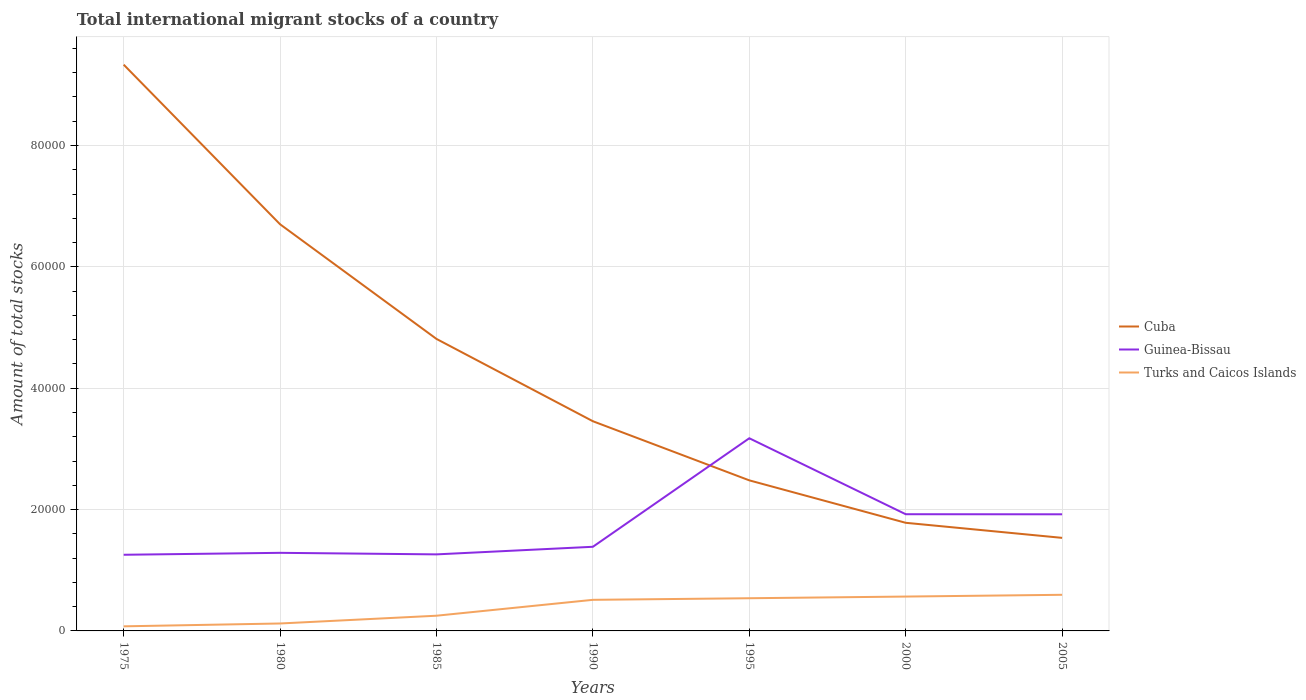How many different coloured lines are there?
Your answer should be very brief. 3. Across all years, what is the maximum amount of total stocks in in Cuba?
Your response must be concise. 1.53e+04. In which year was the amount of total stocks in in Guinea-Bissau maximum?
Offer a terse response. 1975. What is the total amount of total stocks in in Guinea-Bissau in the graph?
Your answer should be very brief. -318. What is the difference between the highest and the second highest amount of total stocks in in Turks and Caicos Islands?
Ensure brevity in your answer.  5196. What is the difference between the highest and the lowest amount of total stocks in in Cuba?
Give a very brief answer. 3. How many lines are there?
Provide a succinct answer. 3. Are the values on the major ticks of Y-axis written in scientific E-notation?
Offer a terse response. No. Does the graph contain grids?
Ensure brevity in your answer.  Yes. How many legend labels are there?
Provide a succinct answer. 3. How are the legend labels stacked?
Offer a terse response. Vertical. What is the title of the graph?
Give a very brief answer. Total international migrant stocks of a country. What is the label or title of the X-axis?
Ensure brevity in your answer.  Years. What is the label or title of the Y-axis?
Give a very brief answer. Amount of total stocks. What is the Amount of total stocks of Cuba in 1975?
Make the answer very short. 9.33e+04. What is the Amount of total stocks of Guinea-Bissau in 1975?
Provide a short and direct response. 1.26e+04. What is the Amount of total stocks in Turks and Caicos Islands in 1975?
Provide a succinct answer. 756. What is the Amount of total stocks of Cuba in 1980?
Offer a very short reply. 6.70e+04. What is the Amount of total stocks in Guinea-Bissau in 1980?
Keep it short and to the point. 1.29e+04. What is the Amount of total stocks of Turks and Caicos Islands in 1980?
Ensure brevity in your answer.  1225. What is the Amount of total stocks in Cuba in 1985?
Make the answer very short. 4.81e+04. What is the Amount of total stocks of Guinea-Bissau in 1985?
Your answer should be very brief. 1.26e+04. What is the Amount of total stocks in Turks and Caicos Islands in 1985?
Your answer should be compact. 2506. What is the Amount of total stocks of Cuba in 1990?
Your answer should be compact. 3.46e+04. What is the Amount of total stocks in Guinea-Bissau in 1990?
Make the answer very short. 1.39e+04. What is the Amount of total stocks of Turks and Caicos Islands in 1990?
Keep it short and to the point. 5124. What is the Amount of total stocks of Cuba in 1995?
Provide a succinct answer. 2.48e+04. What is the Amount of total stocks in Guinea-Bissau in 1995?
Your answer should be compact. 3.17e+04. What is the Amount of total stocks of Turks and Caicos Islands in 1995?
Your answer should be compact. 5386. What is the Amount of total stocks of Cuba in 2000?
Your response must be concise. 1.78e+04. What is the Amount of total stocks of Guinea-Bissau in 2000?
Offer a terse response. 1.92e+04. What is the Amount of total stocks of Turks and Caicos Islands in 2000?
Provide a succinct answer. 5662. What is the Amount of total stocks in Cuba in 2005?
Your response must be concise. 1.53e+04. What is the Amount of total stocks of Guinea-Bissau in 2005?
Your response must be concise. 1.92e+04. What is the Amount of total stocks in Turks and Caicos Islands in 2005?
Give a very brief answer. 5952. Across all years, what is the maximum Amount of total stocks of Cuba?
Give a very brief answer. 9.33e+04. Across all years, what is the maximum Amount of total stocks in Guinea-Bissau?
Provide a succinct answer. 3.17e+04. Across all years, what is the maximum Amount of total stocks in Turks and Caicos Islands?
Give a very brief answer. 5952. Across all years, what is the minimum Amount of total stocks in Cuba?
Give a very brief answer. 1.53e+04. Across all years, what is the minimum Amount of total stocks in Guinea-Bissau?
Provide a succinct answer. 1.26e+04. Across all years, what is the minimum Amount of total stocks of Turks and Caicos Islands?
Offer a terse response. 756. What is the total Amount of total stocks in Cuba in the graph?
Provide a succinct answer. 3.01e+05. What is the total Amount of total stocks in Guinea-Bissau in the graph?
Provide a succinct answer. 1.22e+05. What is the total Amount of total stocks of Turks and Caicos Islands in the graph?
Give a very brief answer. 2.66e+04. What is the difference between the Amount of total stocks of Cuba in 1975 and that in 1980?
Your answer should be compact. 2.63e+04. What is the difference between the Amount of total stocks of Guinea-Bissau in 1975 and that in 1980?
Give a very brief answer. -318. What is the difference between the Amount of total stocks in Turks and Caicos Islands in 1975 and that in 1980?
Your response must be concise. -469. What is the difference between the Amount of total stocks in Cuba in 1975 and that in 1985?
Offer a very short reply. 4.52e+04. What is the difference between the Amount of total stocks in Guinea-Bissau in 1975 and that in 1985?
Provide a succinct answer. -63. What is the difference between the Amount of total stocks of Turks and Caicos Islands in 1975 and that in 1985?
Offer a very short reply. -1750. What is the difference between the Amount of total stocks of Cuba in 1975 and that in 1990?
Keep it short and to the point. 5.88e+04. What is the difference between the Amount of total stocks of Guinea-Bissau in 1975 and that in 1990?
Offer a very short reply. -1315. What is the difference between the Amount of total stocks of Turks and Caicos Islands in 1975 and that in 1990?
Provide a succinct answer. -4368. What is the difference between the Amount of total stocks of Cuba in 1975 and that in 1995?
Keep it short and to the point. 6.85e+04. What is the difference between the Amount of total stocks in Guinea-Bissau in 1975 and that in 1995?
Ensure brevity in your answer.  -1.92e+04. What is the difference between the Amount of total stocks of Turks and Caicos Islands in 1975 and that in 1995?
Provide a succinct answer. -4630. What is the difference between the Amount of total stocks in Cuba in 1975 and that in 2000?
Keep it short and to the point. 7.55e+04. What is the difference between the Amount of total stocks of Guinea-Bissau in 1975 and that in 2000?
Your answer should be compact. -6682. What is the difference between the Amount of total stocks in Turks and Caicos Islands in 1975 and that in 2000?
Provide a succinct answer. -4906. What is the difference between the Amount of total stocks of Cuba in 1975 and that in 2005?
Ensure brevity in your answer.  7.80e+04. What is the difference between the Amount of total stocks in Guinea-Bissau in 1975 and that in 2005?
Offer a very short reply. -6668. What is the difference between the Amount of total stocks of Turks and Caicos Islands in 1975 and that in 2005?
Keep it short and to the point. -5196. What is the difference between the Amount of total stocks of Cuba in 1980 and that in 1985?
Provide a short and direct response. 1.89e+04. What is the difference between the Amount of total stocks in Guinea-Bissau in 1980 and that in 1985?
Offer a very short reply. 255. What is the difference between the Amount of total stocks of Turks and Caicos Islands in 1980 and that in 1985?
Your answer should be very brief. -1281. What is the difference between the Amount of total stocks in Cuba in 1980 and that in 1990?
Your response must be concise. 3.25e+04. What is the difference between the Amount of total stocks in Guinea-Bissau in 1980 and that in 1990?
Provide a succinct answer. -997. What is the difference between the Amount of total stocks of Turks and Caicos Islands in 1980 and that in 1990?
Make the answer very short. -3899. What is the difference between the Amount of total stocks in Cuba in 1980 and that in 1995?
Provide a succinct answer. 4.22e+04. What is the difference between the Amount of total stocks of Guinea-Bissau in 1980 and that in 1995?
Offer a very short reply. -1.89e+04. What is the difference between the Amount of total stocks of Turks and Caicos Islands in 1980 and that in 1995?
Ensure brevity in your answer.  -4161. What is the difference between the Amount of total stocks in Cuba in 1980 and that in 2000?
Your answer should be very brief. 4.92e+04. What is the difference between the Amount of total stocks in Guinea-Bissau in 1980 and that in 2000?
Your answer should be compact. -6364. What is the difference between the Amount of total stocks in Turks and Caicos Islands in 1980 and that in 2000?
Make the answer very short. -4437. What is the difference between the Amount of total stocks of Cuba in 1980 and that in 2005?
Your answer should be very brief. 5.17e+04. What is the difference between the Amount of total stocks in Guinea-Bissau in 1980 and that in 2005?
Your answer should be compact. -6350. What is the difference between the Amount of total stocks in Turks and Caicos Islands in 1980 and that in 2005?
Ensure brevity in your answer.  -4727. What is the difference between the Amount of total stocks in Cuba in 1985 and that in 1990?
Ensure brevity in your answer.  1.36e+04. What is the difference between the Amount of total stocks of Guinea-Bissau in 1985 and that in 1990?
Keep it short and to the point. -1252. What is the difference between the Amount of total stocks in Turks and Caicos Islands in 1985 and that in 1990?
Offer a terse response. -2618. What is the difference between the Amount of total stocks in Cuba in 1985 and that in 1995?
Provide a succinct answer. 2.33e+04. What is the difference between the Amount of total stocks of Guinea-Bissau in 1985 and that in 1995?
Your response must be concise. -1.91e+04. What is the difference between the Amount of total stocks of Turks and Caicos Islands in 1985 and that in 1995?
Provide a short and direct response. -2880. What is the difference between the Amount of total stocks in Cuba in 1985 and that in 2000?
Provide a short and direct response. 3.03e+04. What is the difference between the Amount of total stocks in Guinea-Bissau in 1985 and that in 2000?
Provide a short and direct response. -6619. What is the difference between the Amount of total stocks in Turks and Caicos Islands in 1985 and that in 2000?
Give a very brief answer. -3156. What is the difference between the Amount of total stocks in Cuba in 1985 and that in 2005?
Your answer should be compact. 3.28e+04. What is the difference between the Amount of total stocks in Guinea-Bissau in 1985 and that in 2005?
Keep it short and to the point. -6605. What is the difference between the Amount of total stocks of Turks and Caicos Islands in 1985 and that in 2005?
Give a very brief answer. -3446. What is the difference between the Amount of total stocks in Cuba in 1990 and that in 1995?
Offer a terse response. 9742. What is the difference between the Amount of total stocks of Guinea-Bissau in 1990 and that in 1995?
Your answer should be very brief. -1.79e+04. What is the difference between the Amount of total stocks in Turks and Caicos Islands in 1990 and that in 1995?
Your answer should be compact. -262. What is the difference between the Amount of total stocks of Cuba in 1990 and that in 2000?
Give a very brief answer. 1.67e+04. What is the difference between the Amount of total stocks of Guinea-Bissau in 1990 and that in 2000?
Provide a short and direct response. -5367. What is the difference between the Amount of total stocks in Turks and Caicos Islands in 1990 and that in 2000?
Give a very brief answer. -538. What is the difference between the Amount of total stocks of Cuba in 1990 and that in 2005?
Your answer should be very brief. 1.92e+04. What is the difference between the Amount of total stocks of Guinea-Bissau in 1990 and that in 2005?
Offer a very short reply. -5353. What is the difference between the Amount of total stocks of Turks and Caicos Islands in 1990 and that in 2005?
Provide a succinct answer. -828. What is the difference between the Amount of total stocks in Cuba in 1995 and that in 2000?
Your answer should be compact. 6995. What is the difference between the Amount of total stocks in Guinea-Bissau in 1995 and that in 2000?
Provide a succinct answer. 1.25e+04. What is the difference between the Amount of total stocks of Turks and Caicos Islands in 1995 and that in 2000?
Your response must be concise. -276. What is the difference between the Amount of total stocks of Cuba in 1995 and that in 2005?
Offer a very short reply. 9477. What is the difference between the Amount of total stocks of Guinea-Bissau in 1995 and that in 2005?
Provide a short and direct response. 1.25e+04. What is the difference between the Amount of total stocks in Turks and Caicos Islands in 1995 and that in 2005?
Provide a short and direct response. -566. What is the difference between the Amount of total stocks of Cuba in 2000 and that in 2005?
Your response must be concise. 2482. What is the difference between the Amount of total stocks in Guinea-Bissau in 2000 and that in 2005?
Offer a very short reply. 14. What is the difference between the Amount of total stocks in Turks and Caicos Islands in 2000 and that in 2005?
Make the answer very short. -290. What is the difference between the Amount of total stocks in Cuba in 1975 and the Amount of total stocks in Guinea-Bissau in 1980?
Your answer should be compact. 8.04e+04. What is the difference between the Amount of total stocks in Cuba in 1975 and the Amount of total stocks in Turks and Caicos Islands in 1980?
Your response must be concise. 9.21e+04. What is the difference between the Amount of total stocks in Guinea-Bissau in 1975 and the Amount of total stocks in Turks and Caicos Islands in 1980?
Your answer should be compact. 1.13e+04. What is the difference between the Amount of total stocks in Cuba in 1975 and the Amount of total stocks in Guinea-Bissau in 1985?
Give a very brief answer. 8.07e+04. What is the difference between the Amount of total stocks of Cuba in 1975 and the Amount of total stocks of Turks and Caicos Islands in 1985?
Give a very brief answer. 9.08e+04. What is the difference between the Amount of total stocks of Guinea-Bissau in 1975 and the Amount of total stocks of Turks and Caicos Islands in 1985?
Your answer should be compact. 1.00e+04. What is the difference between the Amount of total stocks in Cuba in 1975 and the Amount of total stocks in Guinea-Bissau in 1990?
Offer a terse response. 7.95e+04. What is the difference between the Amount of total stocks of Cuba in 1975 and the Amount of total stocks of Turks and Caicos Islands in 1990?
Provide a short and direct response. 8.82e+04. What is the difference between the Amount of total stocks in Guinea-Bissau in 1975 and the Amount of total stocks in Turks and Caicos Islands in 1990?
Your answer should be compact. 7427. What is the difference between the Amount of total stocks in Cuba in 1975 and the Amount of total stocks in Guinea-Bissau in 1995?
Offer a very short reply. 6.16e+04. What is the difference between the Amount of total stocks in Cuba in 1975 and the Amount of total stocks in Turks and Caicos Islands in 1995?
Provide a succinct answer. 8.79e+04. What is the difference between the Amount of total stocks of Guinea-Bissau in 1975 and the Amount of total stocks of Turks and Caicos Islands in 1995?
Your response must be concise. 7165. What is the difference between the Amount of total stocks of Cuba in 1975 and the Amount of total stocks of Guinea-Bissau in 2000?
Offer a terse response. 7.41e+04. What is the difference between the Amount of total stocks of Cuba in 1975 and the Amount of total stocks of Turks and Caicos Islands in 2000?
Make the answer very short. 8.77e+04. What is the difference between the Amount of total stocks in Guinea-Bissau in 1975 and the Amount of total stocks in Turks and Caicos Islands in 2000?
Your response must be concise. 6889. What is the difference between the Amount of total stocks in Cuba in 1975 and the Amount of total stocks in Guinea-Bissau in 2005?
Ensure brevity in your answer.  7.41e+04. What is the difference between the Amount of total stocks of Cuba in 1975 and the Amount of total stocks of Turks and Caicos Islands in 2005?
Your response must be concise. 8.74e+04. What is the difference between the Amount of total stocks of Guinea-Bissau in 1975 and the Amount of total stocks of Turks and Caicos Islands in 2005?
Offer a very short reply. 6599. What is the difference between the Amount of total stocks of Cuba in 1980 and the Amount of total stocks of Guinea-Bissau in 1985?
Keep it short and to the point. 5.44e+04. What is the difference between the Amount of total stocks in Cuba in 1980 and the Amount of total stocks in Turks and Caicos Islands in 1985?
Your response must be concise. 6.45e+04. What is the difference between the Amount of total stocks of Guinea-Bissau in 1980 and the Amount of total stocks of Turks and Caicos Islands in 1985?
Keep it short and to the point. 1.04e+04. What is the difference between the Amount of total stocks of Cuba in 1980 and the Amount of total stocks of Guinea-Bissau in 1990?
Make the answer very short. 5.31e+04. What is the difference between the Amount of total stocks of Cuba in 1980 and the Amount of total stocks of Turks and Caicos Islands in 1990?
Provide a succinct answer. 6.19e+04. What is the difference between the Amount of total stocks of Guinea-Bissau in 1980 and the Amount of total stocks of Turks and Caicos Islands in 1990?
Keep it short and to the point. 7745. What is the difference between the Amount of total stocks of Cuba in 1980 and the Amount of total stocks of Guinea-Bissau in 1995?
Give a very brief answer. 3.53e+04. What is the difference between the Amount of total stocks of Cuba in 1980 and the Amount of total stocks of Turks and Caicos Islands in 1995?
Your answer should be very brief. 6.16e+04. What is the difference between the Amount of total stocks in Guinea-Bissau in 1980 and the Amount of total stocks in Turks and Caicos Islands in 1995?
Make the answer very short. 7483. What is the difference between the Amount of total stocks in Cuba in 1980 and the Amount of total stocks in Guinea-Bissau in 2000?
Offer a very short reply. 4.78e+04. What is the difference between the Amount of total stocks of Cuba in 1980 and the Amount of total stocks of Turks and Caicos Islands in 2000?
Provide a succinct answer. 6.13e+04. What is the difference between the Amount of total stocks in Guinea-Bissau in 1980 and the Amount of total stocks in Turks and Caicos Islands in 2000?
Keep it short and to the point. 7207. What is the difference between the Amount of total stocks in Cuba in 1980 and the Amount of total stocks in Guinea-Bissau in 2005?
Ensure brevity in your answer.  4.78e+04. What is the difference between the Amount of total stocks in Cuba in 1980 and the Amount of total stocks in Turks and Caicos Islands in 2005?
Give a very brief answer. 6.11e+04. What is the difference between the Amount of total stocks of Guinea-Bissau in 1980 and the Amount of total stocks of Turks and Caicos Islands in 2005?
Your response must be concise. 6917. What is the difference between the Amount of total stocks of Cuba in 1985 and the Amount of total stocks of Guinea-Bissau in 1990?
Provide a succinct answer. 3.43e+04. What is the difference between the Amount of total stocks in Cuba in 1985 and the Amount of total stocks in Turks and Caicos Islands in 1990?
Your answer should be very brief. 4.30e+04. What is the difference between the Amount of total stocks of Guinea-Bissau in 1985 and the Amount of total stocks of Turks and Caicos Islands in 1990?
Offer a terse response. 7490. What is the difference between the Amount of total stocks in Cuba in 1985 and the Amount of total stocks in Guinea-Bissau in 1995?
Provide a short and direct response. 1.64e+04. What is the difference between the Amount of total stocks of Cuba in 1985 and the Amount of total stocks of Turks and Caicos Islands in 1995?
Offer a terse response. 4.27e+04. What is the difference between the Amount of total stocks in Guinea-Bissau in 1985 and the Amount of total stocks in Turks and Caicos Islands in 1995?
Keep it short and to the point. 7228. What is the difference between the Amount of total stocks of Cuba in 1985 and the Amount of total stocks of Guinea-Bissau in 2000?
Your answer should be compact. 2.89e+04. What is the difference between the Amount of total stocks in Cuba in 1985 and the Amount of total stocks in Turks and Caicos Islands in 2000?
Keep it short and to the point. 4.25e+04. What is the difference between the Amount of total stocks of Guinea-Bissau in 1985 and the Amount of total stocks of Turks and Caicos Islands in 2000?
Keep it short and to the point. 6952. What is the difference between the Amount of total stocks of Cuba in 1985 and the Amount of total stocks of Guinea-Bissau in 2005?
Give a very brief answer. 2.89e+04. What is the difference between the Amount of total stocks in Cuba in 1985 and the Amount of total stocks in Turks and Caicos Islands in 2005?
Keep it short and to the point. 4.22e+04. What is the difference between the Amount of total stocks in Guinea-Bissau in 1985 and the Amount of total stocks in Turks and Caicos Islands in 2005?
Offer a very short reply. 6662. What is the difference between the Amount of total stocks in Cuba in 1990 and the Amount of total stocks in Guinea-Bissau in 1995?
Your response must be concise. 2806. What is the difference between the Amount of total stocks in Cuba in 1990 and the Amount of total stocks in Turks and Caicos Islands in 1995?
Offer a terse response. 2.92e+04. What is the difference between the Amount of total stocks of Guinea-Bissau in 1990 and the Amount of total stocks of Turks and Caicos Islands in 1995?
Ensure brevity in your answer.  8480. What is the difference between the Amount of total stocks of Cuba in 1990 and the Amount of total stocks of Guinea-Bissau in 2000?
Your response must be concise. 1.53e+04. What is the difference between the Amount of total stocks in Cuba in 1990 and the Amount of total stocks in Turks and Caicos Islands in 2000?
Provide a short and direct response. 2.89e+04. What is the difference between the Amount of total stocks of Guinea-Bissau in 1990 and the Amount of total stocks of Turks and Caicos Islands in 2000?
Your answer should be very brief. 8204. What is the difference between the Amount of total stocks in Cuba in 1990 and the Amount of total stocks in Guinea-Bissau in 2005?
Ensure brevity in your answer.  1.53e+04. What is the difference between the Amount of total stocks in Cuba in 1990 and the Amount of total stocks in Turks and Caicos Islands in 2005?
Give a very brief answer. 2.86e+04. What is the difference between the Amount of total stocks in Guinea-Bissau in 1990 and the Amount of total stocks in Turks and Caicos Islands in 2005?
Provide a short and direct response. 7914. What is the difference between the Amount of total stocks in Cuba in 1995 and the Amount of total stocks in Guinea-Bissau in 2000?
Your response must be concise. 5580. What is the difference between the Amount of total stocks of Cuba in 1995 and the Amount of total stocks of Turks and Caicos Islands in 2000?
Make the answer very short. 1.92e+04. What is the difference between the Amount of total stocks in Guinea-Bissau in 1995 and the Amount of total stocks in Turks and Caicos Islands in 2000?
Your answer should be very brief. 2.61e+04. What is the difference between the Amount of total stocks in Cuba in 1995 and the Amount of total stocks in Guinea-Bissau in 2005?
Ensure brevity in your answer.  5594. What is the difference between the Amount of total stocks in Cuba in 1995 and the Amount of total stocks in Turks and Caicos Islands in 2005?
Give a very brief answer. 1.89e+04. What is the difference between the Amount of total stocks of Guinea-Bissau in 1995 and the Amount of total stocks of Turks and Caicos Islands in 2005?
Ensure brevity in your answer.  2.58e+04. What is the difference between the Amount of total stocks of Cuba in 2000 and the Amount of total stocks of Guinea-Bissau in 2005?
Offer a terse response. -1401. What is the difference between the Amount of total stocks in Cuba in 2000 and the Amount of total stocks in Turks and Caicos Islands in 2005?
Offer a very short reply. 1.19e+04. What is the difference between the Amount of total stocks in Guinea-Bissau in 2000 and the Amount of total stocks in Turks and Caicos Islands in 2005?
Make the answer very short. 1.33e+04. What is the average Amount of total stocks of Cuba per year?
Offer a terse response. 4.30e+04. What is the average Amount of total stocks of Guinea-Bissau per year?
Provide a short and direct response. 1.74e+04. What is the average Amount of total stocks of Turks and Caicos Islands per year?
Give a very brief answer. 3801.57. In the year 1975, what is the difference between the Amount of total stocks in Cuba and Amount of total stocks in Guinea-Bissau?
Keep it short and to the point. 8.08e+04. In the year 1975, what is the difference between the Amount of total stocks of Cuba and Amount of total stocks of Turks and Caicos Islands?
Give a very brief answer. 9.26e+04. In the year 1975, what is the difference between the Amount of total stocks in Guinea-Bissau and Amount of total stocks in Turks and Caicos Islands?
Offer a very short reply. 1.18e+04. In the year 1980, what is the difference between the Amount of total stocks in Cuba and Amount of total stocks in Guinea-Bissau?
Offer a very short reply. 5.41e+04. In the year 1980, what is the difference between the Amount of total stocks in Cuba and Amount of total stocks in Turks and Caicos Islands?
Keep it short and to the point. 6.58e+04. In the year 1980, what is the difference between the Amount of total stocks of Guinea-Bissau and Amount of total stocks of Turks and Caicos Islands?
Keep it short and to the point. 1.16e+04. In the year 1985, what is the difference between the Amount of total stocks of Cuba and Amount of total stocks of Guinea-Bissau?
Provide a short and direct response. 3.55e+04. In the year 1985, what is the difference between the Amount of total stocks of Cuba and Amount of total stocks of Turks and Caicos Islands?
Your answer should be very brief. 4.56e+04. In the year 1985, what is the difference between the Amount of total stocks of Guinea-Bissau and Amount of total stocks of Turks and Caicos Islands?
Your response must be concise. 1.01e+04. In the year 1990, what is the difference between the Amount of total stocks in Cuba and Amount of total stocks in Guinea-Bissau?
Keep it short and to the point. 2.07e+04. In the year 1990, what is the difference between the Amount of total stocks of Cuba and Amount of total stocks of Turks and Caicos Islands?
Make the answer very short. 2.94e+04. In the year 1990, what is the difference between the Amount of total stocks of Guinea-Bissau and Amount of total stocks of Turks and Caicos Islands?
Provide a succinct answer. 8742. In the year 1995, what is the difference between the Amount of total stocks in Cuba and Amount of total stocks in Guinea-Bissau?
Provide a succinct answer. -6936. In the year 1995, what is the difference between the Amount of total stocks in Cuba and Amount of total stocks in Turks and Caicos Islands?
Make the answer very short. 1.94e+04. In the year 1995, what is the difference between the Amount of total stocks of Guinea-Bissau and Amount of total stocks of Turks and Caicos Islands?
Give a very brief answer. 2.64e+04. In the year 2000, what is the difference between the Amount of total stocks of Cuba and Amount of total stocks of Guinea-Bissau?
Your answer should be very brief. -1415. In the year 2000, what is the difference between the Amount of total stocks of Cuba and Amount of total stocks of Turks and Caicos Islands?
Provide a succinct answer. 1.22e+04. In the year 2000, what is the difference between the Amount of total stocks of Guinea-Bissau and Amount of total stocks of Turks and Caicos Islands?
Your answer should be compact. 1.36e+04. In the year 2005, what is the difference between the Amount of total stocks in Cuba and Amount of total stocks in Guinea-Bissau?
Ensure brevity in your answer.  -3883. In the year 2005, what is the difference between the Amount of total stocks of Cuba and Amount of total stocks of Turks and Caicos Islands?
Offer a very short reply. 9384. In the year 2005, what is the difference between the Amount of total stocks of Guinea-Bissau and Amount of total stocks of Turks and Caicos Islands?
Ensure brevity in your answer.  1.33e+04. What is the ratio of the Amount of total stocks of Cuba in 1975 to that in 1980?
Your answer should be very brief. 1.39. What is the ratio of the Amount of total stocks of Guinea-Bissau in 1975 to that in 1980?
Your answer should be compact. 0.98. What is the ratio of the Amount of total stocks in Turks and Caicos Islands in 1975 to that in 1980?
Keep it short and to the point. 0.62. What is the ratio of the Amount of total stocks in Cuba in 1975 to that in 1985?
Your answer should be very brief. 1.94. What is the ratio of the Amount of total stocks of Guinea-Bissau in 1975 to that in 1985?
Offer a very short reply. 0.99. What is the ratio of the Amount of total stocks of Turks and Caicos Islands in 1975 to that in 1985?
Give a very brief answer. 0.3. What is the ratio of the Amount of total stocks in Cuba in 1975 to that in 1990?
Offer a terse response. 2.7. What is the ratio of the Amount of total stocks of Guinea-Bissau in 1975 to that in 1990?
Provide a short and direct response. 0.91. What is the ratio of the Amount of total stocks of Turks and Caicos Islands in 1975 to that in 1990?
Provide a short and direct response. 0.15. What is the ratio of the Amount of total stocks in Cuba in 1975 to that in 1995?
Keep it short and to the point. 3.76. What is the ratio of the Amount of total stocks of Guinea-Bissau in 1975 to that in 1995?
Provide a short and direct response. 0.4. What is the ratio of the Amount of total stocks of Turks and Caicos Islands in 1975 to that in 1995?
Your answer should be compact. 0.14. What is the ratio of the Amount of total stocks in Cuba in 1975 to that in 2000?
Keep it short and to the point. 5.24. What is the ratio of the Amount of total stocks in Guinea-Bissau in 1975 to that in 2000?
Ensure brevity in your answer.  0.65. What is the ratio of the Amount of total stocks of Turks and Caicos Islands in 1975 to that in 2000?
Keep it short and to the point. 0.13. What is the ratio of the Amount of total stocks in Cuba in 1975 to that in 2005?
Your answer should be compact. 6.08. What is the ratio of the Amount of total stocks in Guinea-Bissau in 1975 to that in 2005?
Ensure brevity in your answer.  0.65. What is the ratio of the Amount of total stocks in Turks and Caicos Islands in 1975 to that in 2005?
Your answer should be compact. 0.13. What is the ratio of the Amount of total stocks in Cuba in 1980 to that in 1985?
Make the answer very short. 1.39. What is the ratio of the Amount of total stocks of Guinea-Bissau in 1980 to that in 1985?
Your response must be concise. 1.02. What is the ratio of the Amount of total stocks in Turks and Caicos Islands in 1980 to that in 1985?
Ensure brevity in your answer.  0.49. What is the ratio of the Amount of total stocks of Cuba in 1980 to that in 1990?
Offer a very short reply. 1.94. What is the ratio of the Amount of total stocks in Guinea-Bissau in 1980 to that in 1990?
Offer a very short reply. 0.93. What is the ratio of the Amount of total stocks in Turks and Caicos Islands in 1980 to that in 1990?
Offer a very short reply. 0.24. What is the ratio of the Amount of total stocks in Cuba in 1980 to that in 1995?
Your answer should be very brief. 2.7. What is the ratio of the Amount of total stocks in Guinea-Bissau in 1980 to that in 1995?
Provide a succinct answer. 0.41. What is the ratio of the Amount of total stocks in Turks and Caicos Islands in 1980 to that in 1995?
Offer a terse response. 0.23. What is the ratio of the Amount of total stocks in Cuba in 1980 to that in 2000?
Provide a short and direct response. 3.76. What is the ratio of the Amount of total stocks of Guinea-Bissau in 1980 to that in 2000?
Your response must be concise. 0.67. What is the ratio of the Amount of total stocks of Turks and Caicos Islands in 1980 to that in 2000?
Provide a succinct answer. 0.22. What is the ratio of the Amount of total stocks of Cuba in 1980 to that in 2005?
Ensure brevity in your answer.  4.37. What is the ratio of the Amount of total stocks of Guinea-Bissau in 1980 to that in 2005?
Make the answer very short. 0.67. What is the ratio of the Amount of total stocks of Turks and Caicos Islands in 1980 to that in 2005?
Give a very brief answer. 0.21. What is the ratio of the Amount of total stocks in Cuba in 1985 to that in 1990?
Keep it short and to the point. 1.39. What is the ratio of the Amount of total stocks in Guinea-Bissau in 1985 to that in 1990?
Ensure brevity in your answer.  0.91. What is the ratio of the Amount of total stocks of Turks and Caicos Islands in 1985 to that in 1990?
Your response must be concise. 0.49. What is the ratio of the Amount of total stocks in Cuba in 1985 to that in 1995?
Your answer should be compact. 1.94. What is the ratio of the Amount of total stocks of Guinea-Bissau in 1985 to that in 1995?
Your answer should be compact. 0.4. What is the ratio of the Amount of total stocks in Turks and Caicos Islands in 1985 to that in 1995?
Your answer should be compact. 0.47. What is the ratio of the Amount of total stocks of Cuba in 1985 to that in 2000?
Offer a terse response. 2.7. What is the ratio of the Amount of total stocks in Guinea-Bissau in 1985 to that in 2000?
Keep it short and to the point. 0.66. What is the ratio of the Amount of total stocks in Turks and Caicos Islands in 1985 to that in 2000?
Offer a very short reply. 0.44. What is the ratio of the Amount of total stocks of Cuba in 1985 to that in 2005?
Offer a terse response. 3.14. What is the ratio of the Amount of total stocks in Guinea-Bissau in 1985 to that in 2005?
Offer a very short reply. 0.66. What is the ratio of the Amount of total stocks in Turks and Caicos Islands in 1985 to that in 2005?
Keep it short and to the point. 0.42. What is the ratio of the Amount of total stocks in Cuba in 1990 to that in 1995?
Your answer should be compact. 1.39. What is the ratio of the Amount of total stocks of Guinea-Bissau in 1990 to that in 1995?
Offer a very short reply. 0.44. What is the ratio of the Amount of total stocks of Turks and Caicos Islands in 1990 to that in 1995?
Your answer should be compact. 0.95. What is the ratio of the Amount of total stocks in Cuba in 1990 to that in 2000?
Ensure brevity in your answer.  1.94. What is the ratio of the Amount of total stocks of Guinea-Bissau in 1990 to that in 2000?
Ensure brevity in your answer.  0.72. What is the ratio of the Amount of total stocks of Turks and Caicos Islands in 1990 to that in 2000?
Provide a succinct answer. 0.91. What is the ratio of the Amount of total stocks in Cuba in 1990 to that in 2005?
Keep it short and to the point. 2.25. What is the ratio of the Amount of total stocks in Guinea-Bissau in 1990 to that in 2005?
Keep it short and to the point. 0.72. What is the ratio of the Amount of total stocks of Turks and Caicos Islands in 1990 to that in 2005?
Offer a terse response. 0.86. What is the ratio of the Amount of total stocks of Cuba in 1995 to that in 2000?
Keep it short and to the point. 1.39. What is the ratio of the Amount of total stocks of Guinea-Bissau in 1995 to that in 2000?
Your response must be concise. 1.65. What is the ratio of the Amount of total stocks of Turks and Caicos Islands in 1995 to that in 2000?
Make the answer very short. 0.95. What is the ratio of the Amount of total stocks in Cuba in 1995 to that in 2005?
Ensure brevity in your answer.  1.62. What is the ratio of the Amount of total stocks of Guinea-Bissau in 1995 to that in 2005?
Ensure brevity in your answer.  1.65. What is the ratio of the Amount of total stocks in Turks and Caicos Islands in 1995 to that in 2005?
Keep it short and to the point. 0.9. What is the ratio of the Amount of total stocks in Cuba in 2000 to that in 2005?
Make the answer very short. 1.16. What is the ratio of the Amount of total stocks of Guinea-Bissau in 2000 to that in 2005?
Provide a succinct answer. 1. What is the ratio of the Amount of total stocks of Turks and Caicos Islands in 2000 to that in 2005?
Give a very brief answer. 0.95. What is the difference between the highest and the second highest Amount of total stocks in Cuba?
Your answer should be very brief. 2.63e+04. What is the difference between the highest and the second highest Amount of total stocks of Guinea-Bissau?
Give a very brief answer. 1.25e+04. What is the difference between the highest and the second highest Amount of total stocks in Turks and Caicos Islands?
Give a very brief answer. 290. What is the difference between the highest and the lowest Amount of total stocks in Cuba?
Offer a very short reply. 7.80e+04. What is the difference between the highest and the lowest Amount of total stocks in Guinea-Bissau?
Your answer should be compact. 1.92e+04. What is the difference between the highest and the lowest Amount of total stocks in Turks and Caicos Islands?
Provide a succinct answer. 5196. 